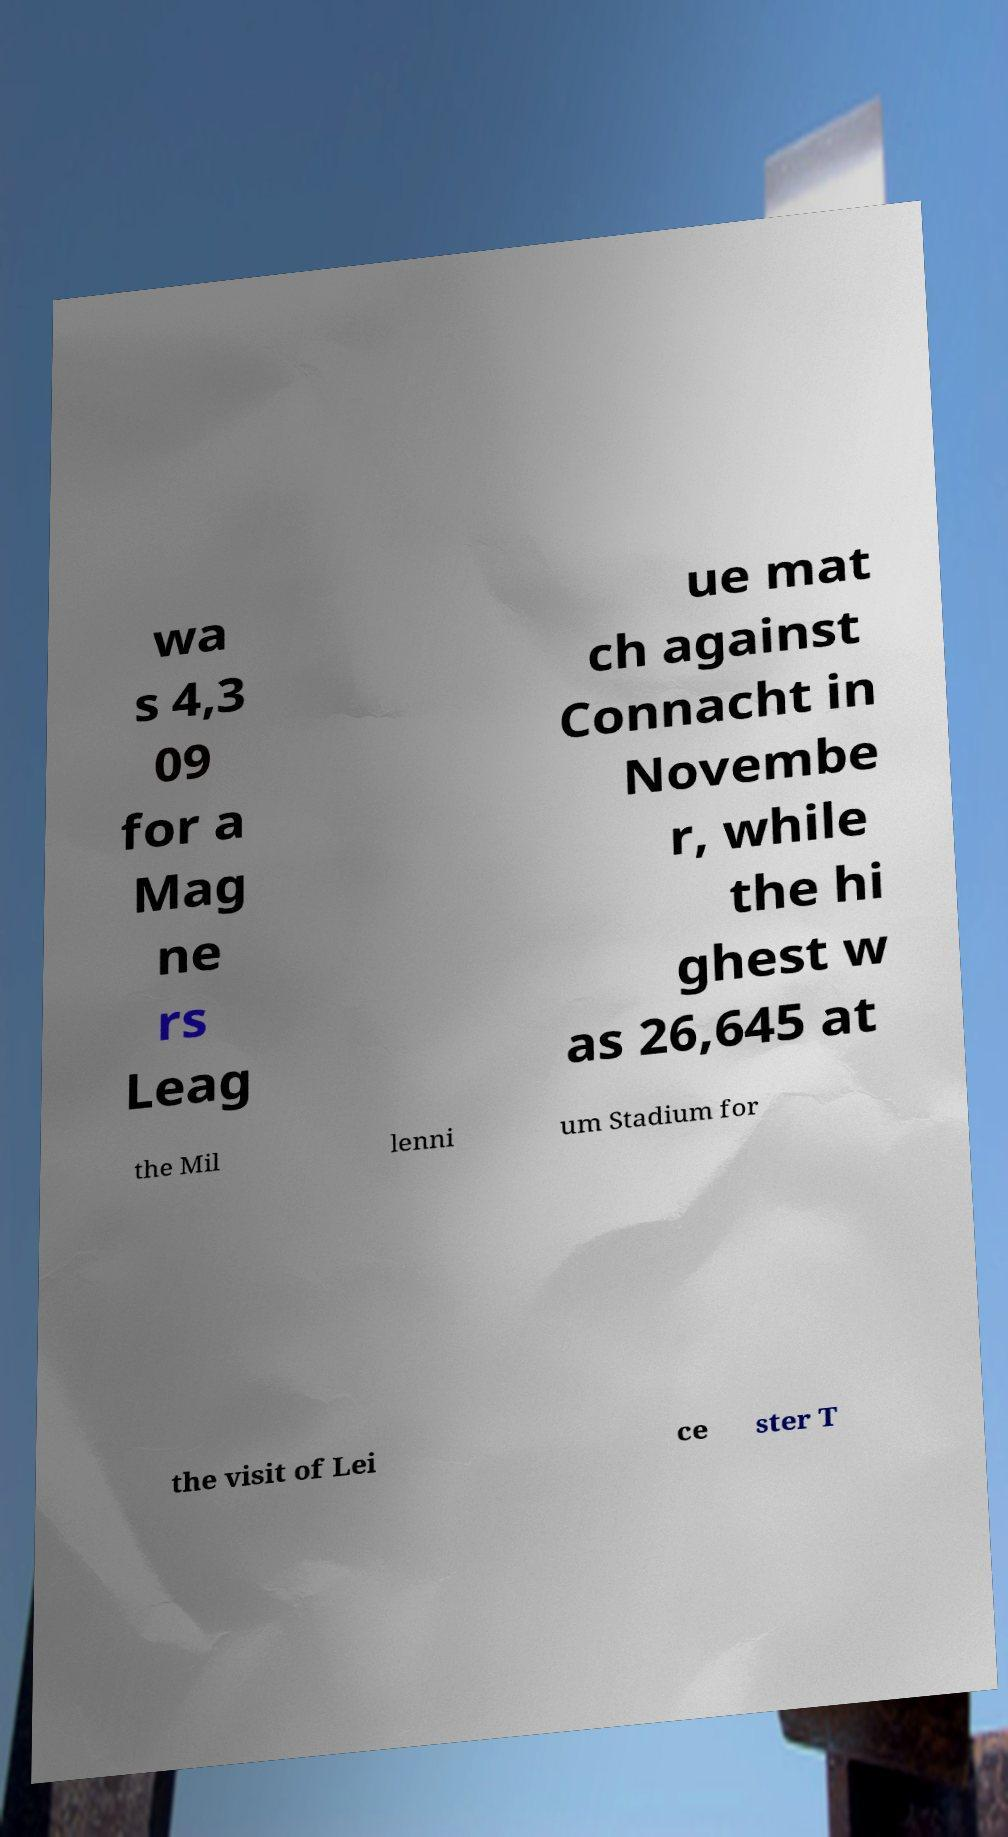Can you read and provide the text displayed in the image?This photo seems to have some interesting text. Can you extract and type it out for me? wa s 4,3 09 for a Mag ne rs Leag ue mat ch against Connacht in Novembe r, while the hi ghest w as 26,645 at the Mil lenni um Stadium for the visit of Lei ce ster T 